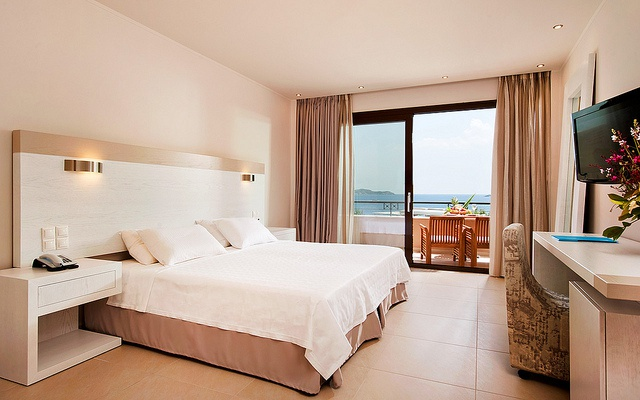Describe the objects in this image and their specific colors. I can see bed in tan, lightgray, and brown tones, couch in tan, maroon, black, and brown tones, tv in tan, black, gray, and maroon tones, potted plant in tan, black, maroon, and olive tones, and chair in tan, maroon, and brown tones in this image. 